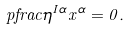<formula> <loc_0><loc_0><loc_500><loc_500>\ p f r a c { \eta ^ { I \alpha } } { x ^ { \alpha } } = 0 .</formula> 